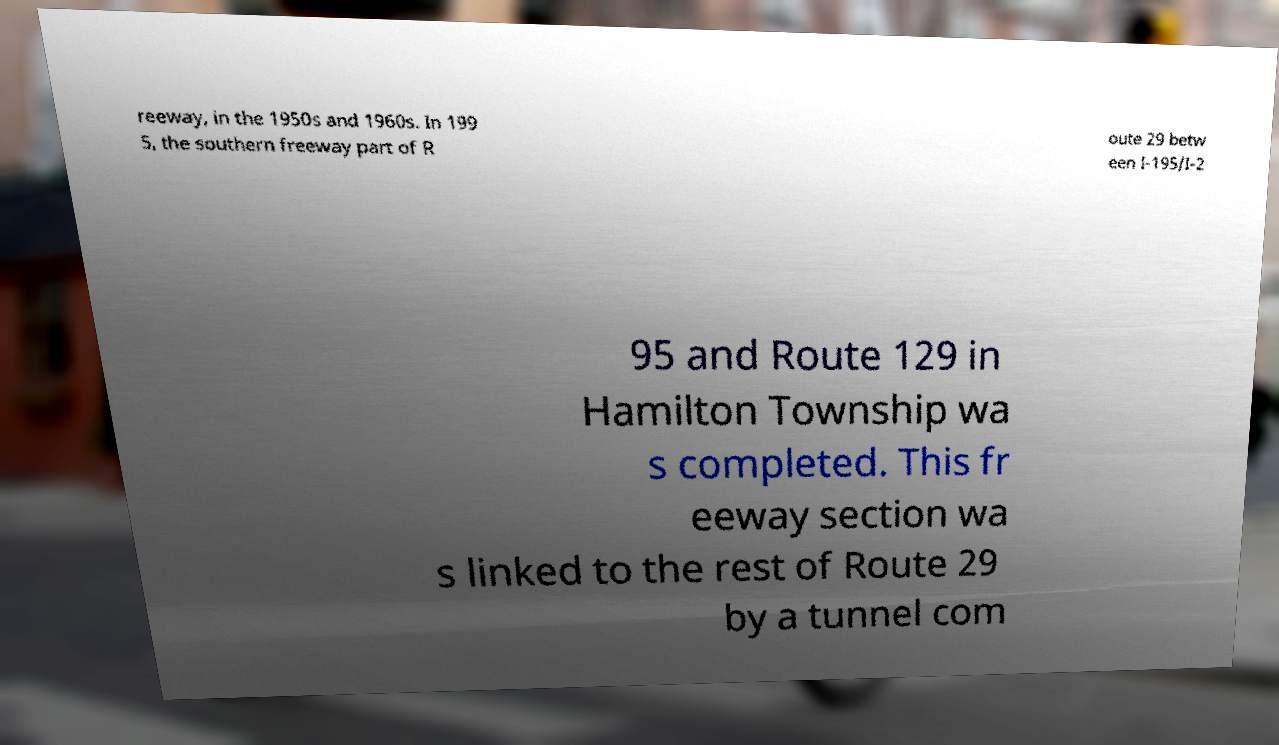There's text embedded in this image that I need extracted. Can you transcribe it verbatim? reeway, in the 1950s and 1960s. In 199 5, the southern freeway part of R oute 29 betw een I-195/I-2 95 and Route 129 in Hamilton Township wa s completed. This fr eeway section wa s linked to the rest of Route 29 by a tunnel com 